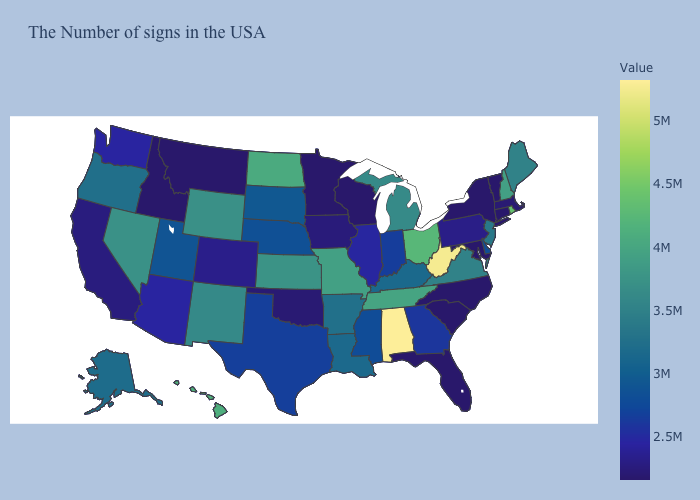Does Virginia have a higher value than Missouri?
Give a very brief answer. No. Among the states that border Wyoming , which have the lowest value?
Be succinct. Montana, Idaho. Among the states that border Connecticut , which have the lowest value?
Write a very short answer. New York. Does Oregon have the lowest value in the West?
Concise answer only. No. Is the legend a continuous bar?
Short answer required. Yes. 